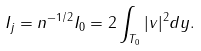<formula> <loc_0><loc_0><loc_500><loc_500>I _ { j } = n ^ { - 1 / 2 } I _ { 0 } = 2 \int _ { T _ { 0 } } | v | ^ { 2 } d y .</formula> 